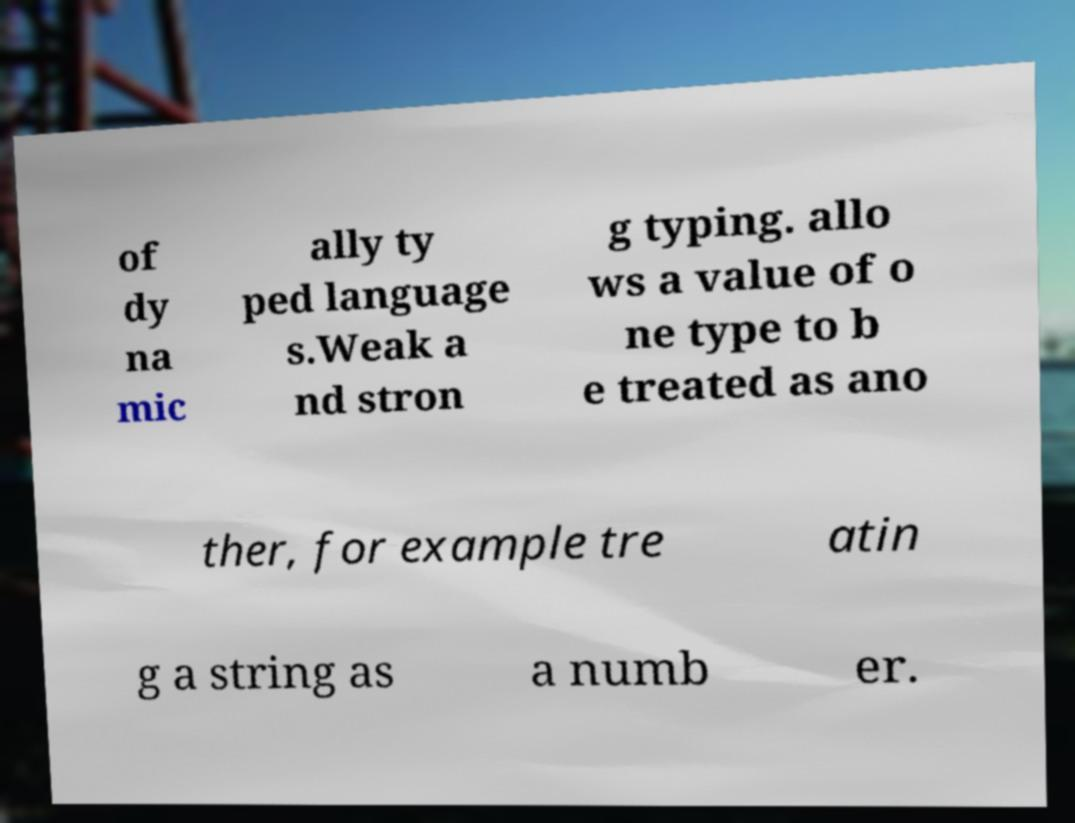Please identify and transcribe the text found in this image. of dy na mic ally ty ped language s.Weak a nd stron g typing. allo ws a value of o ne type to b e treated as ano ther, for example tre atin g a string as a numb er. 